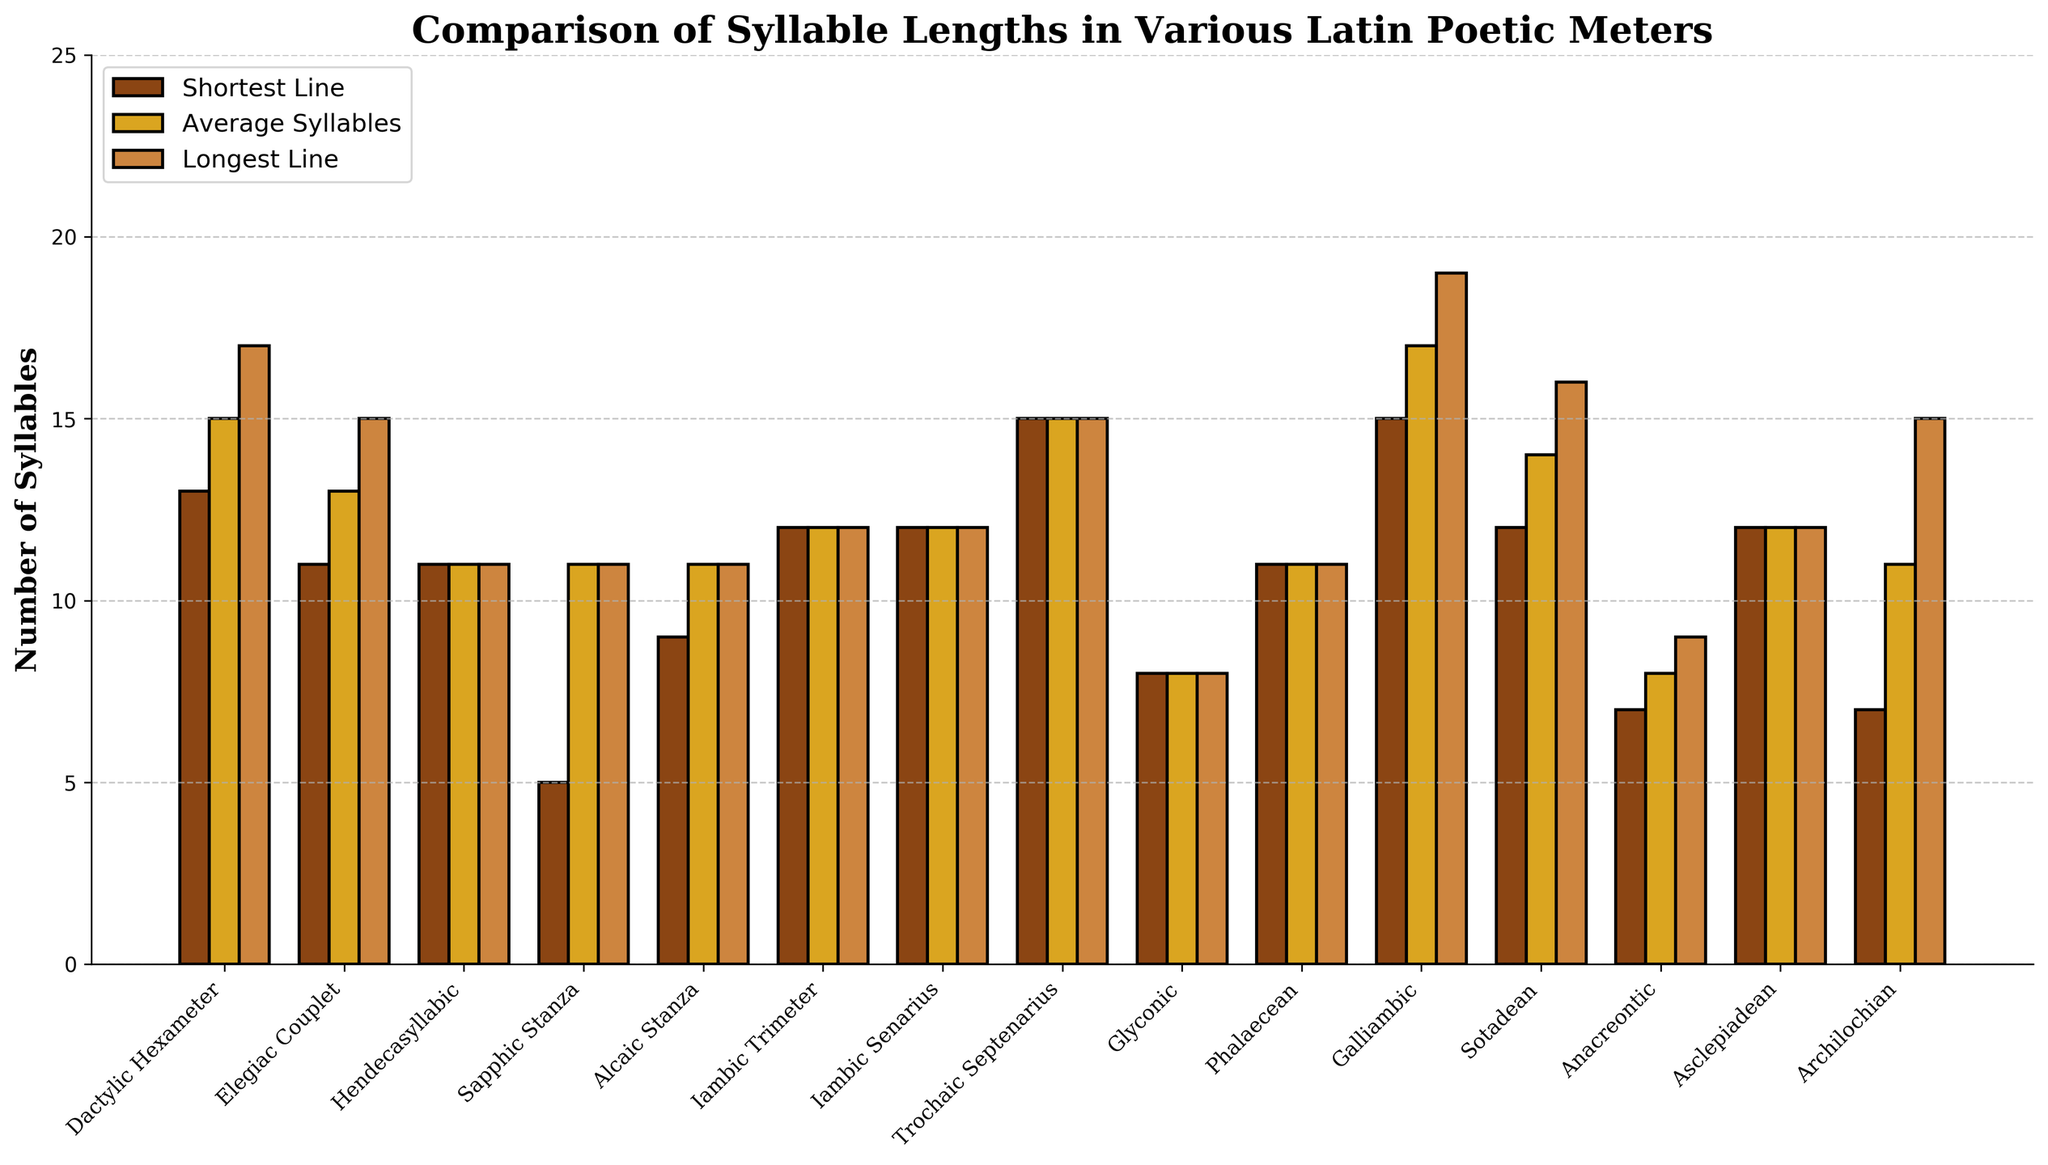What's the poetic meter with the lowest longest line of syllables? The longest line in various meters can be compared by looking at the height of the bars representing 'Longest Line'. The shortest longest line is 8 syllables for Glyconic.
Answer: Glyconic Which meter has the largest difference between the shortest and longest line? Subtract the 'Shortest Line' value from the 'Longest Line' value for each meter and compare the results. Galliambic has the largest difference with 19 - 15 = 4 syllables gap.
Answer: Galliambic Which meters have an average syllable length of exactly 11? Identify the bars representing 'Average Syllables' that reach the value of 11. These meters are Hendecasyllabic, Sapphic Stanza, Alcaic Stanza, and Phalaecean.
Answer: Hendecasyllabic, Sapphic Stanza, Alcaic Stanza, Phalaecean What is the range of syllables in Dactylic Hexameter? Range is the difference between the longest and shortest bars for Dactylic Hexameter. It's 17 (Longest) - 13 (Shortest) = 4 syllables.
Answer: 4 Which meter has the longest average syllable count? Compare the 'Average Syllables' bars and identify the highest one. Galliambic has the longest average syllable count with 17 syllables per line.
Answer: Galliambic What is the sum of the longest lines' syllable counts for Elegiac Couplet and Sotadean? Add the 'Longest Line' syllables for Elegiac Couplet and Sotadean. 15 (Elegiac Couplet) + 16 (Sotadean) = 31 syllables.
Answer: 31 Is there any meter where the shortest line and longest line have the same syllable count? Check if any meter has equal heights for 'Shortest Line' and 'Longest Line' bars. Hendecasyllabic, Iambic Trimeter, Iambic Senarius, Trochaic Septenarius, Glyconic, Phalaecean, and Asclepiadean all match this condition.
Answer: Yes Which meter shows the smallest average syllable count? Inspect the 'Average Syllables' bars to find the lowest bar. Glyconic and Anacreontic both have the smallest average syllable count of 8.
Answer: Glyconic, Anacreontic 